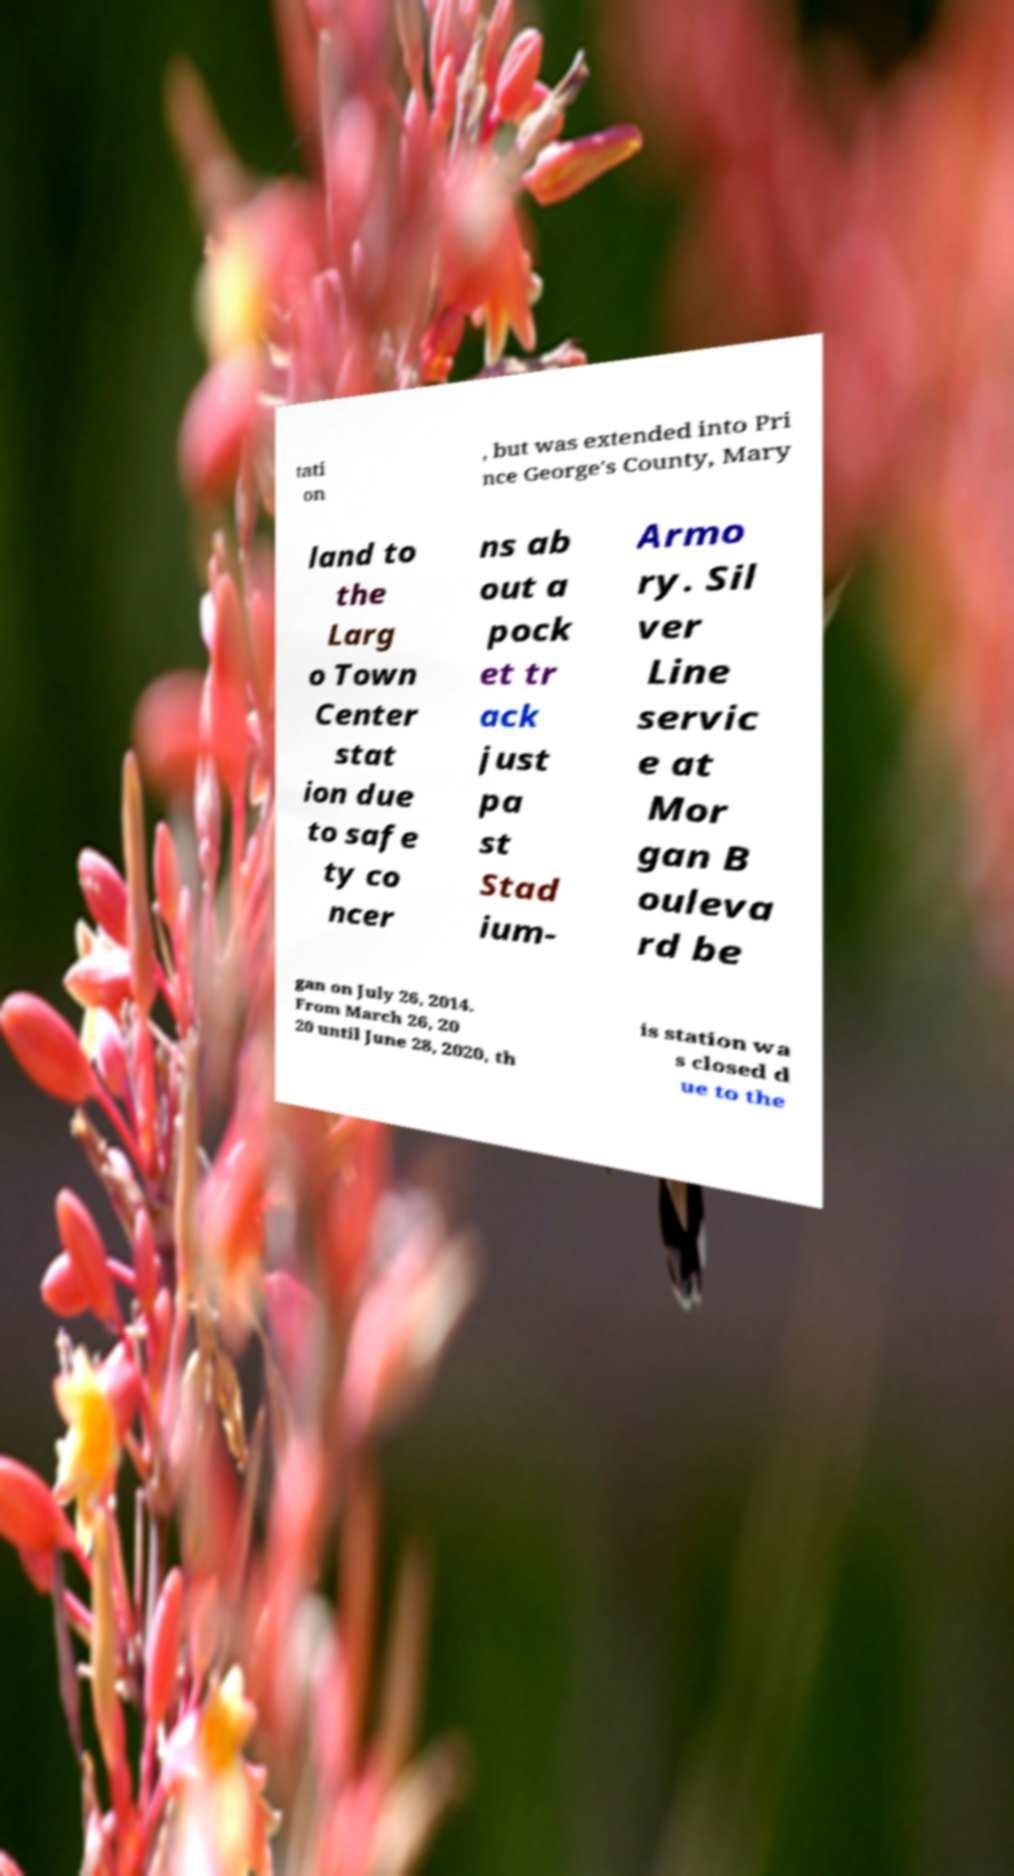Can you accurately transcribe the text from the provided image for me? tati on , but was extended into Pri nce George's County, Mary land to the Larg o Town Center stat ion due to safe ty co ncer ns ab out a pock et tr ack just pa st Stad ium- Armo ry. Sil ver Line servic e at Mor gan B ouleva rd be gan on July 26, 2014. From March 26, 20 20 until June 28, 2020, th is station wa s closed d ue to the 